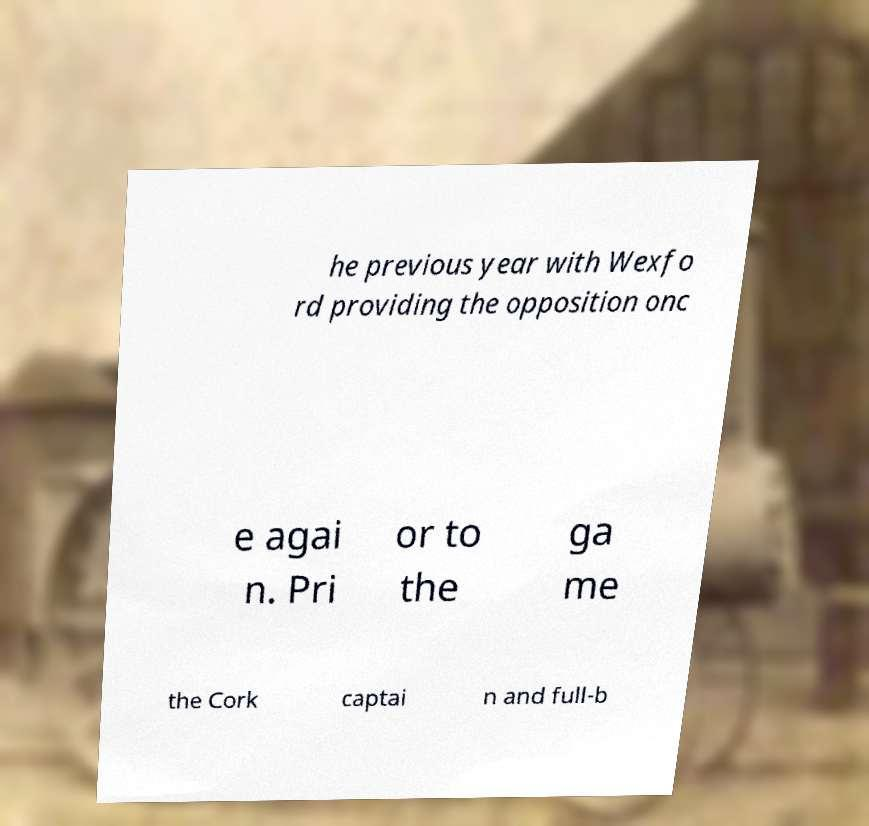What messages or text are displayed in this image? I need them in a readable, typed format. he previous year with Wexfo rd providing the opposition onc e agai n. Pri or to the ga me the Cork captai n and full-b 